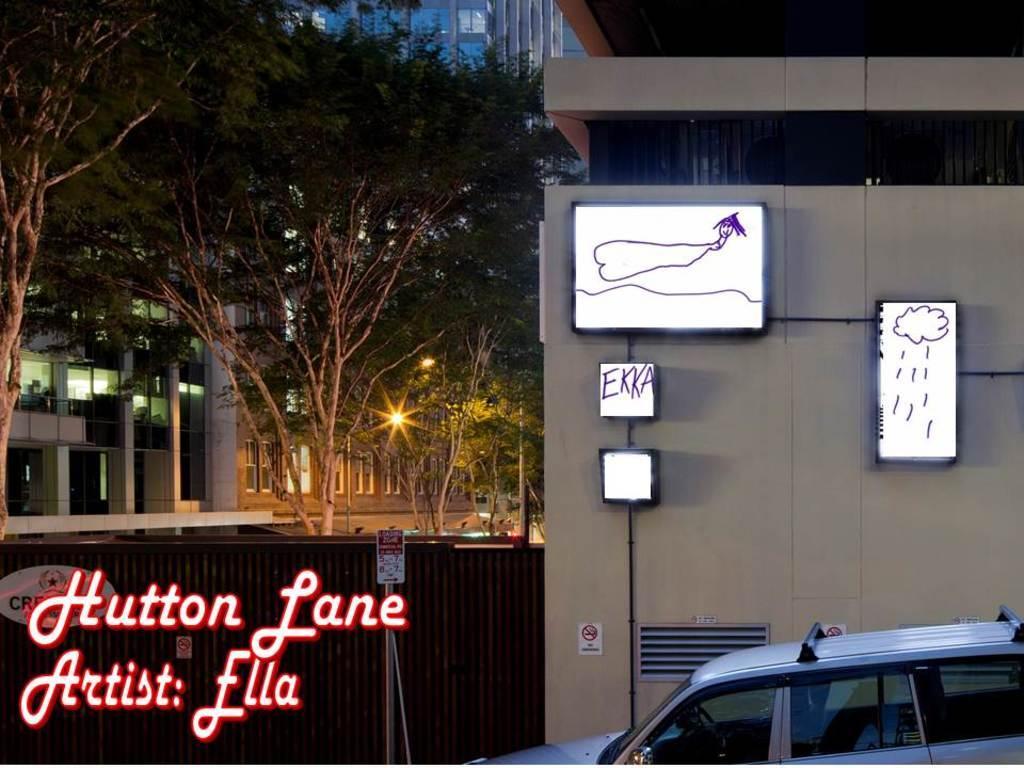Could you give a brief overview of what you see in this image? In this image, we can see a few buildings, windows, walls, pillars, trees, lights, boards, stickers, sign board with pole. At the bottom, we can see a vehicle. Here we can see some text. 